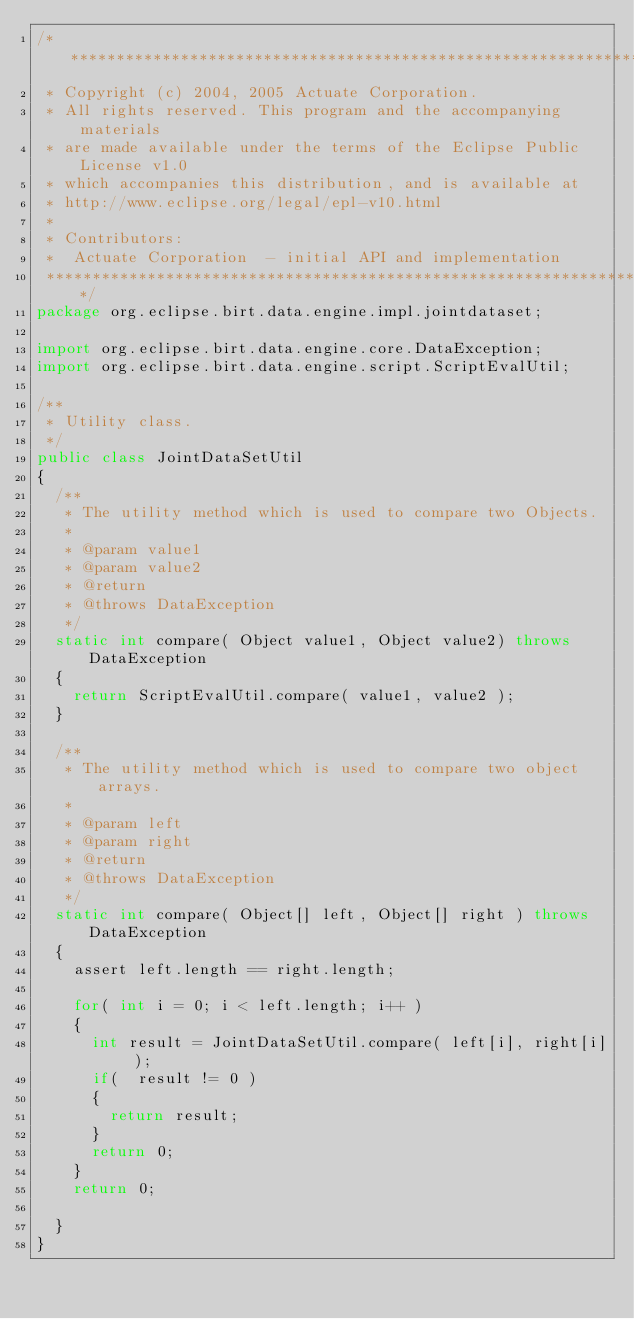<code> <loc_0><loc_0><loc_500><loc_500><_Java_>/*******************************************************************************
 * Copyright (c) 2004, 2005 Actuate Corporation.
 * All rights reserved. This program and the accompanying materials
 * are made available under the terms of the Eclipse Public License v1.0
 * which accompanies this distribution, and is available at
 * http://www.eclipse.org/legal/epl-v10.html
 *
 * Contributors:
 *  Actuate Corporation  - initial API and implementation
 *******************************************************************************/
package org.eclipse.birt.data.engine.impl.jointdataset;

import org.eclipse.birt.data.engine.core.DataException;
import org.eclipse.birt.data.engine.script.ScriptEvalUtil;

/**
 * Utility class.
 */
public class JointDataSetUtil
{
	/**
	 * The utility method which is used to compare two Objects. 
	 * 
	 * @param value1
	 * @param value2
	 * @return
	 * @throws DataException
	 */
	static int compare( Object value1, Object value2) throws DataException
	{
		return ScriptEvalUtil.compare( value1, value2 );
	}
	
	/**
	 * The utility method which is used to compare two object arrays.
	 * 
	 * @param left
	 * @param right
	 * @return
	 * @throws DataException
	 */
	static int compare( Object[] left, Object[] right ) throws DataException
	{
		assert left.length == right.length;
		
		for( int i = 0; i < left.length; i++ )
		{
			int result = JointDataSetUtil.compare( left[i], right[i] ); 
			if(  result != 0 )
			{
				return result;
			}
			return 0;
		}
		return 0;
		
	}
}
</code> 